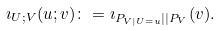<formula> <loc_0><loc_0><loc_500><loc_500>\imath _ { U ; V } ( u ; v ) \colon = \imath _ { P _ { V | U = u } | | P _ { V } } ( v ) .</formula> 